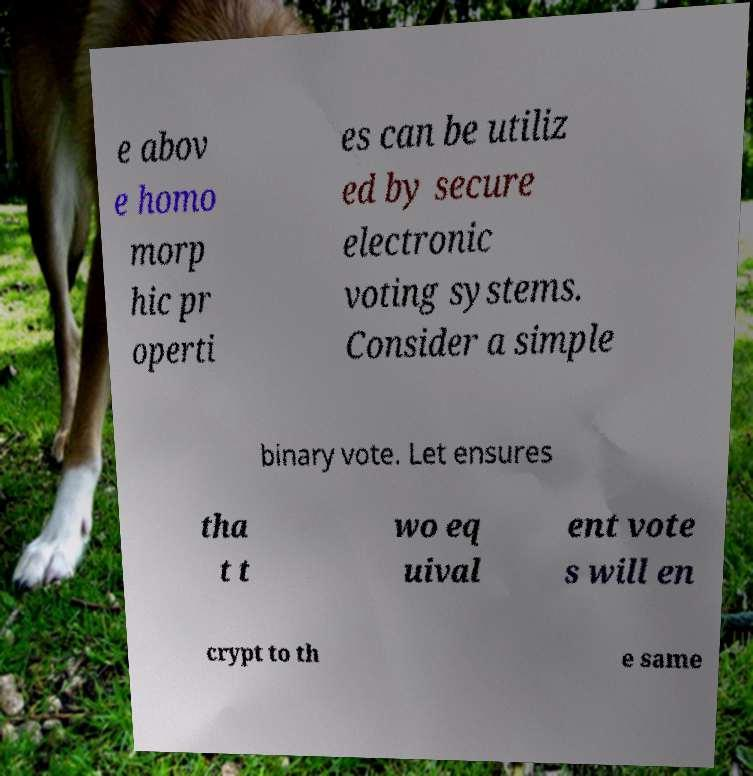Could you extract and type out the text from this image? e abov e homo morp hic pr operti es can be utiliz ed by secure electronic voting systems. Consider a simple binary vote. Let ensures tha t t wo eq uival ent vote s will en crypt to th e same 